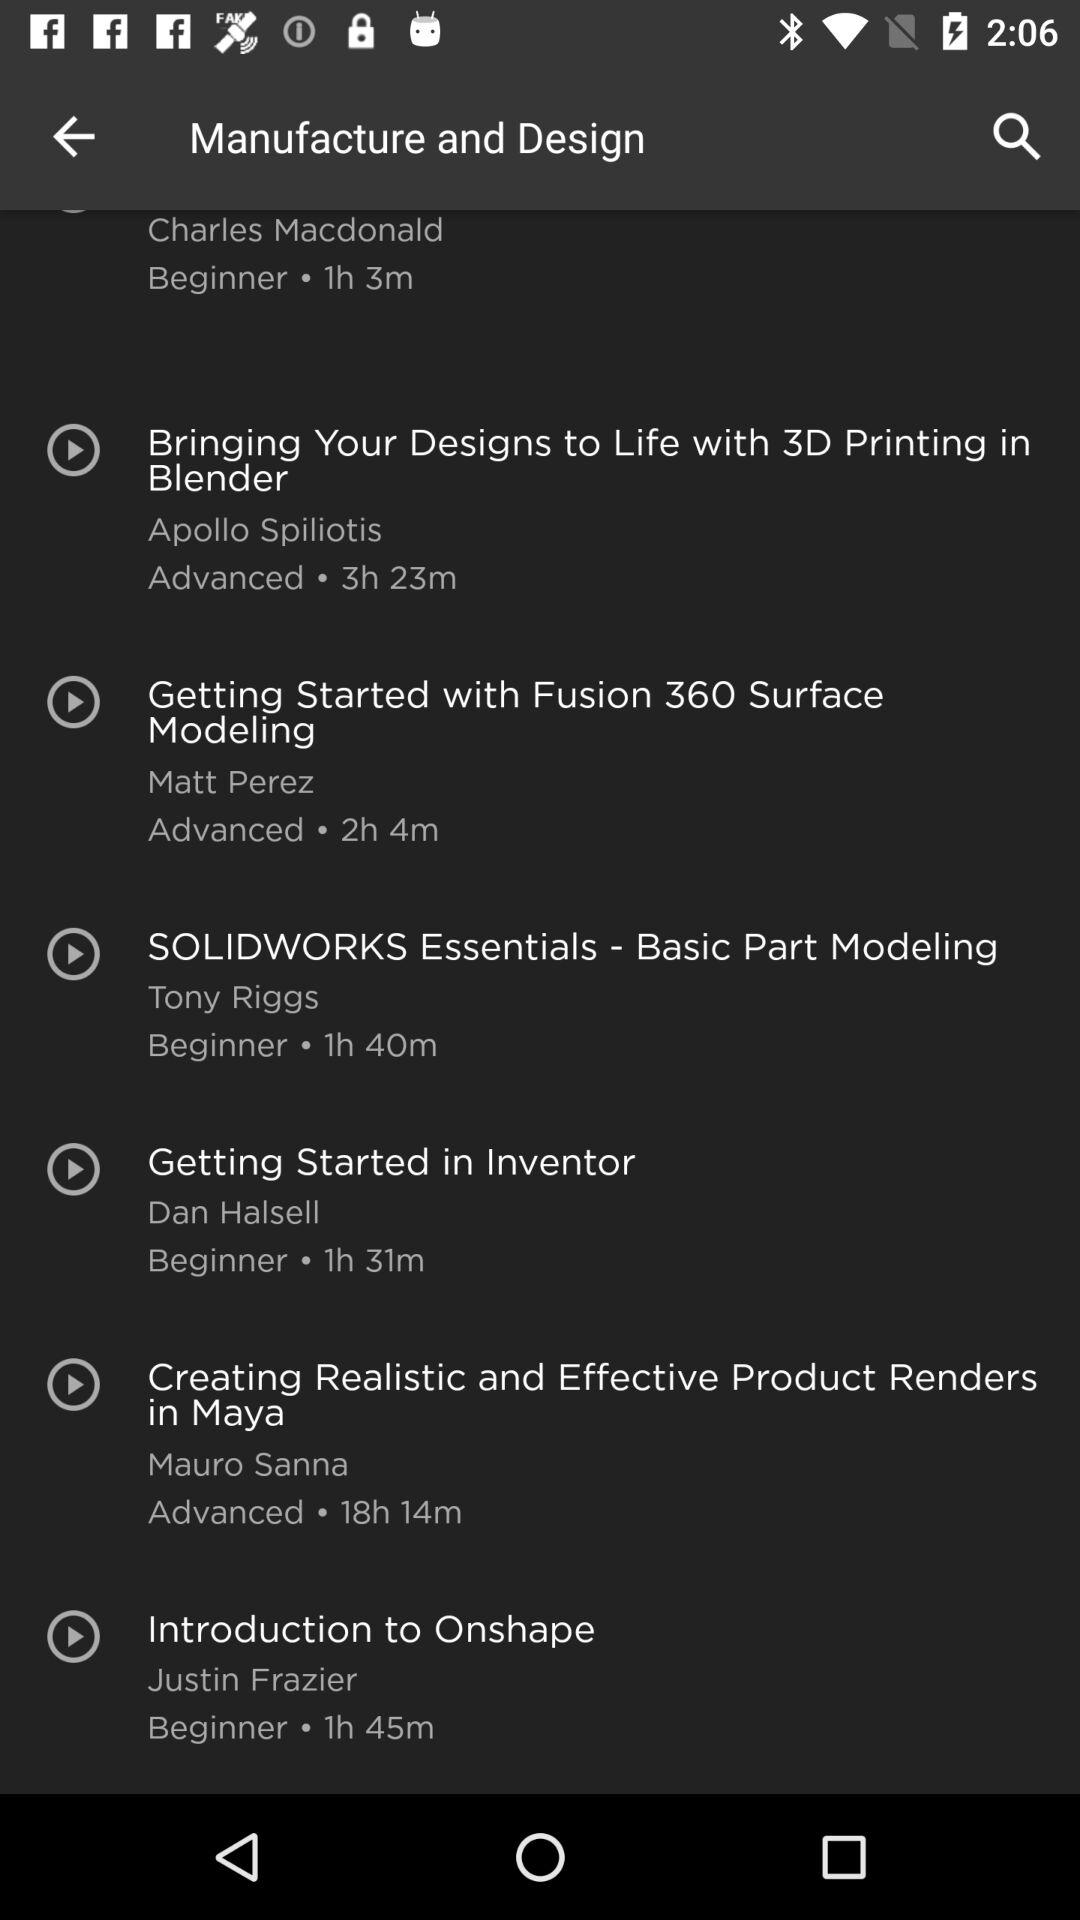How long is the video by Tony Riggs? The video by Tony Riggs is 1 hour 40 minutes long. 